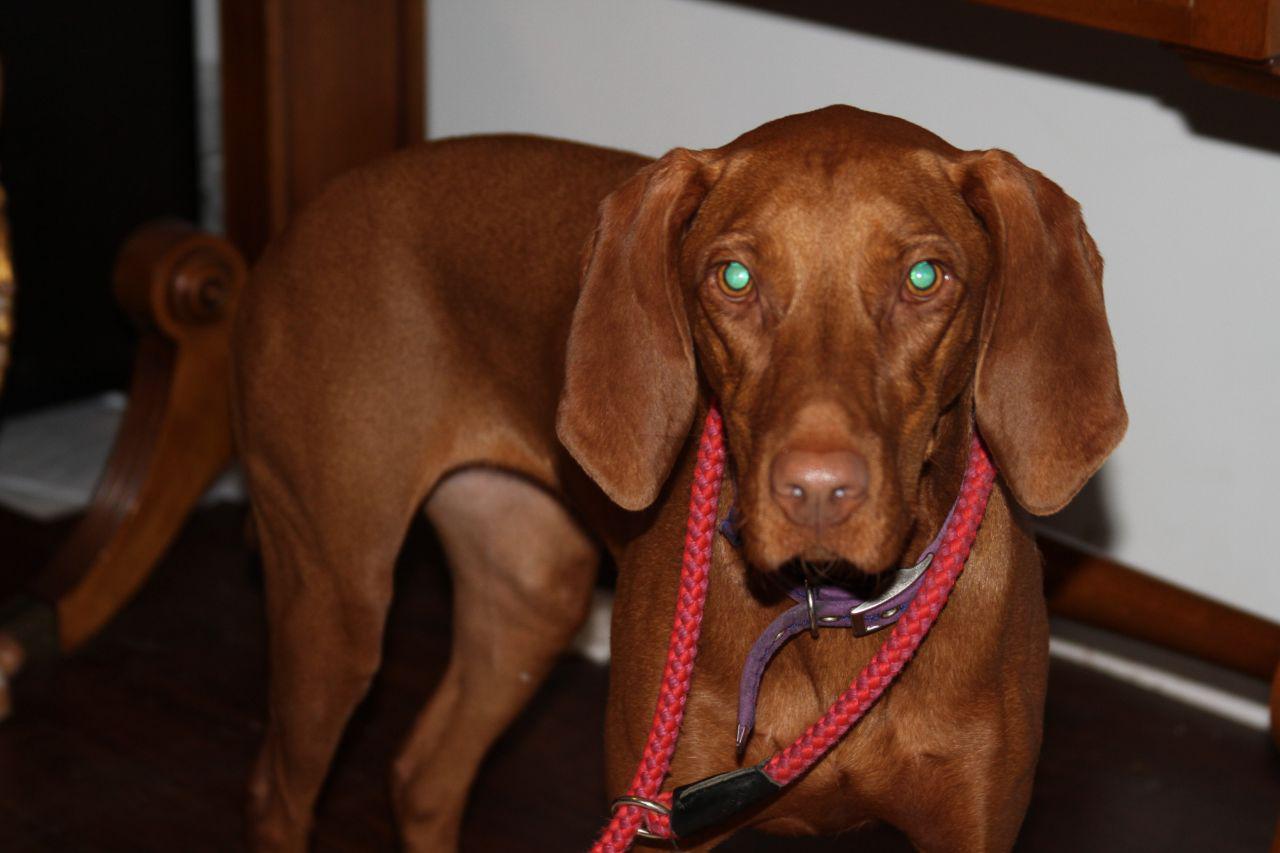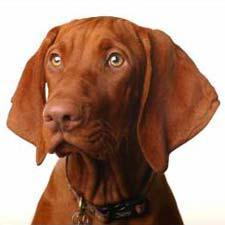The first image is the image on the left, the second image is the image on the right. Analyze the images presented: Is the assertion "At least one hound has a red collar around its neck." valid? Answer yes or no. Yes. The first image is the image on the left, the second image is the image on the right. For the images shown, is this caption "The left image contains one reddish-orange dog wearing a red braided cord around its neck." true? Answer yes or no. Yes. 